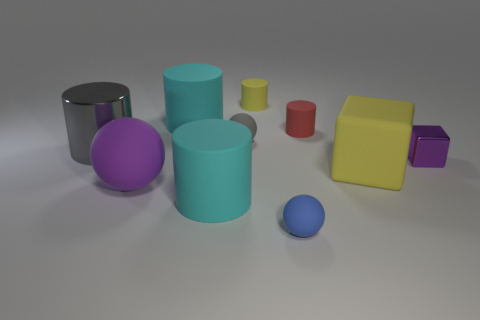Subtract all red rubber cylinders. How many cylinders are left? 4 Subtract all green cylinders. Subtract all brown balls. How many cylinders are left? 5 Subtract all blocks. How many objects are left? 8 Subtract 1 purple cubes. How many objects are left? 9 Subtract all large objects. Subtract all cylinders. How many objects are left? 0 Add 3 large yellow rubber things. How many large yellow rubber things are left? 4 Add 2 cyan balls. How many cyan balls exist? 2 